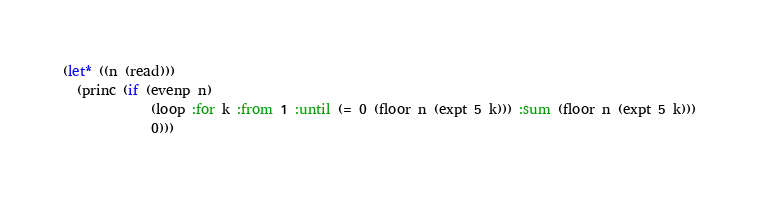Convert code to text. <code><loc_0><loc_0><loc_500><loc_500><_Lisp_>(let* ((n (read)))
  (princ (if (evenp n)
             (loop :for k :from 1 :until (= 0 (floor n (expt 5 k))) :sum (floor n (expt 5 k)))
             0)))</code> 